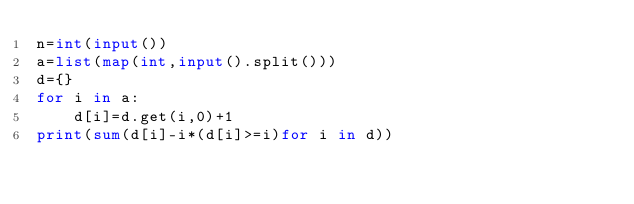Convert code to text. <code><loc_0><loc_0><loc_500><loc_500><_Python_>n=int(input())
a=list(map(int,input().split()))
d={}
for i in a:
    d[i]=d.get(i,0)+1
print(sum(d[i]-i*(d[i]>=i)for i in d))
</code> 